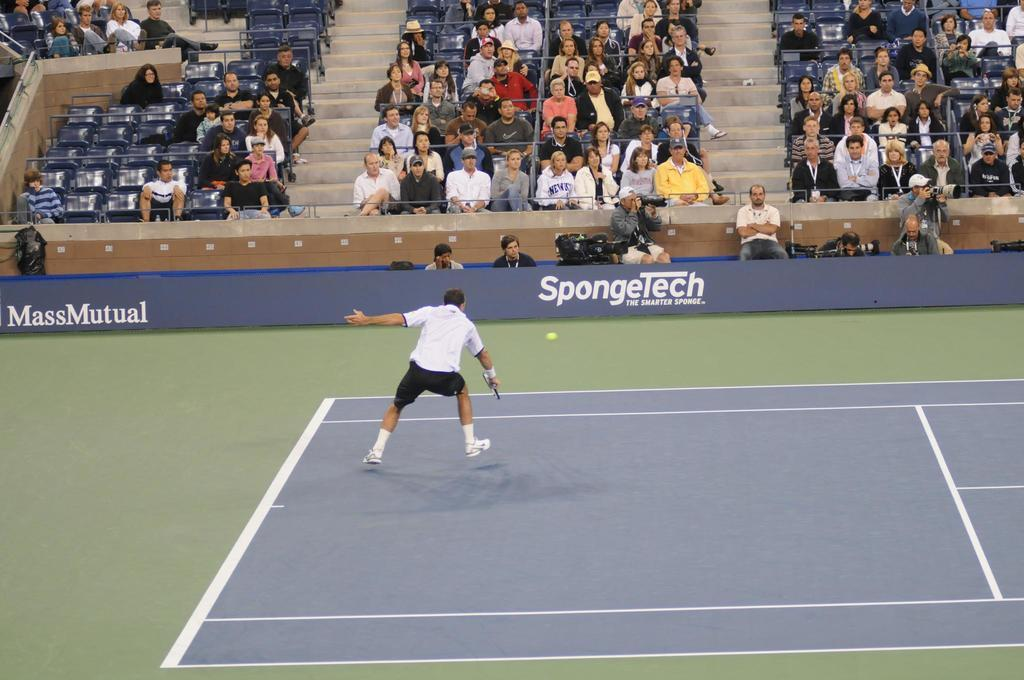What is the man in the image doing? The man is playing in the ground. What object is associated with the man's activity in the image? There is a ball in the image. What are the other people in the image doing? There are persons sitting on chairs in the image. What can be seen in the background of the image? There is a hoarding in the image. What type of leather material is being used to make the cat's toy in the image? There is no cat or toy present in the image, so it is not possible to determine the type of leather material being used. 